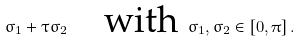<formula> <loc_0><loc_0><loc_500><loc_500>\sigma _ { 1 } + \tau \sigma _ { 2 } \quad \text {with } \sigma _ { 1 } , \sigma _ { 2 } \in [ 0 , \pi ] \, .</formula> 